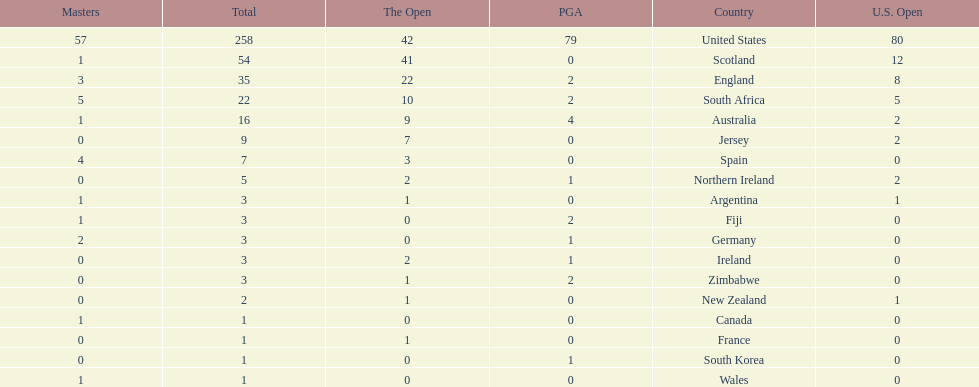Can you give me this table as a dict? {'header': ['Masters', 'Total', 'The Open', 'PGA', 'Country', 'U.S. Open'], 'rows': [['57', '258', '42', '79', 'United States', '80'], ['1', '54', '41', '0', 'Scotland', '12'], ['3', '35', '22', '2', 'England', '8'], ['5', '22', '10', '2', 'South Africa', '5'], ['1', '16', '9', '4', 'Australia', '2'], ['0', '9', '7', '0', 'Jersey', '2'], ['4', '7', '3', '0', 'Spain', '0'], ['0', '5', '2', '1', 'Northern Ireland', '2'], ['1', '3', '1', '0', 'Argentina', '1'], ['1', '3', '0', '2', 'Fiji', '0'], ['2', '3', '0', '1', 'Germany', '0'], ['0', '3', '2', '1', 'Ireland', '0'], ['0', '3', '1', '2', 'Zimbabwe', '0'], ['0', '2', '1', '0', 'New Zealand', '1'], ['1', '1', '0', '0', 'Canada', '0'], ['0', '1', '1', '0', 'France', '0'], ['0', '1', '0', '1', 'South Korea', '0'], ['1', '1', '0', '0', 'Wales', '0']]} How many total championships does spain have? 7. 